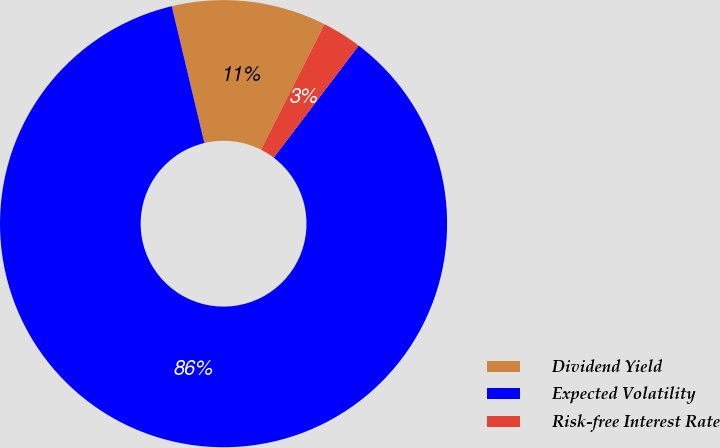Convert chart to OTSL. <chart><loc_0><loc_0><loc_500><loc_500><pie_chart><fcel>Dividend Yield<fcel>Expected Volatility<fcel>Risk-free Interest Rate<nl><fcel>11.18%<fcel>85.95%<fcel>2.87%<nl></chart> 